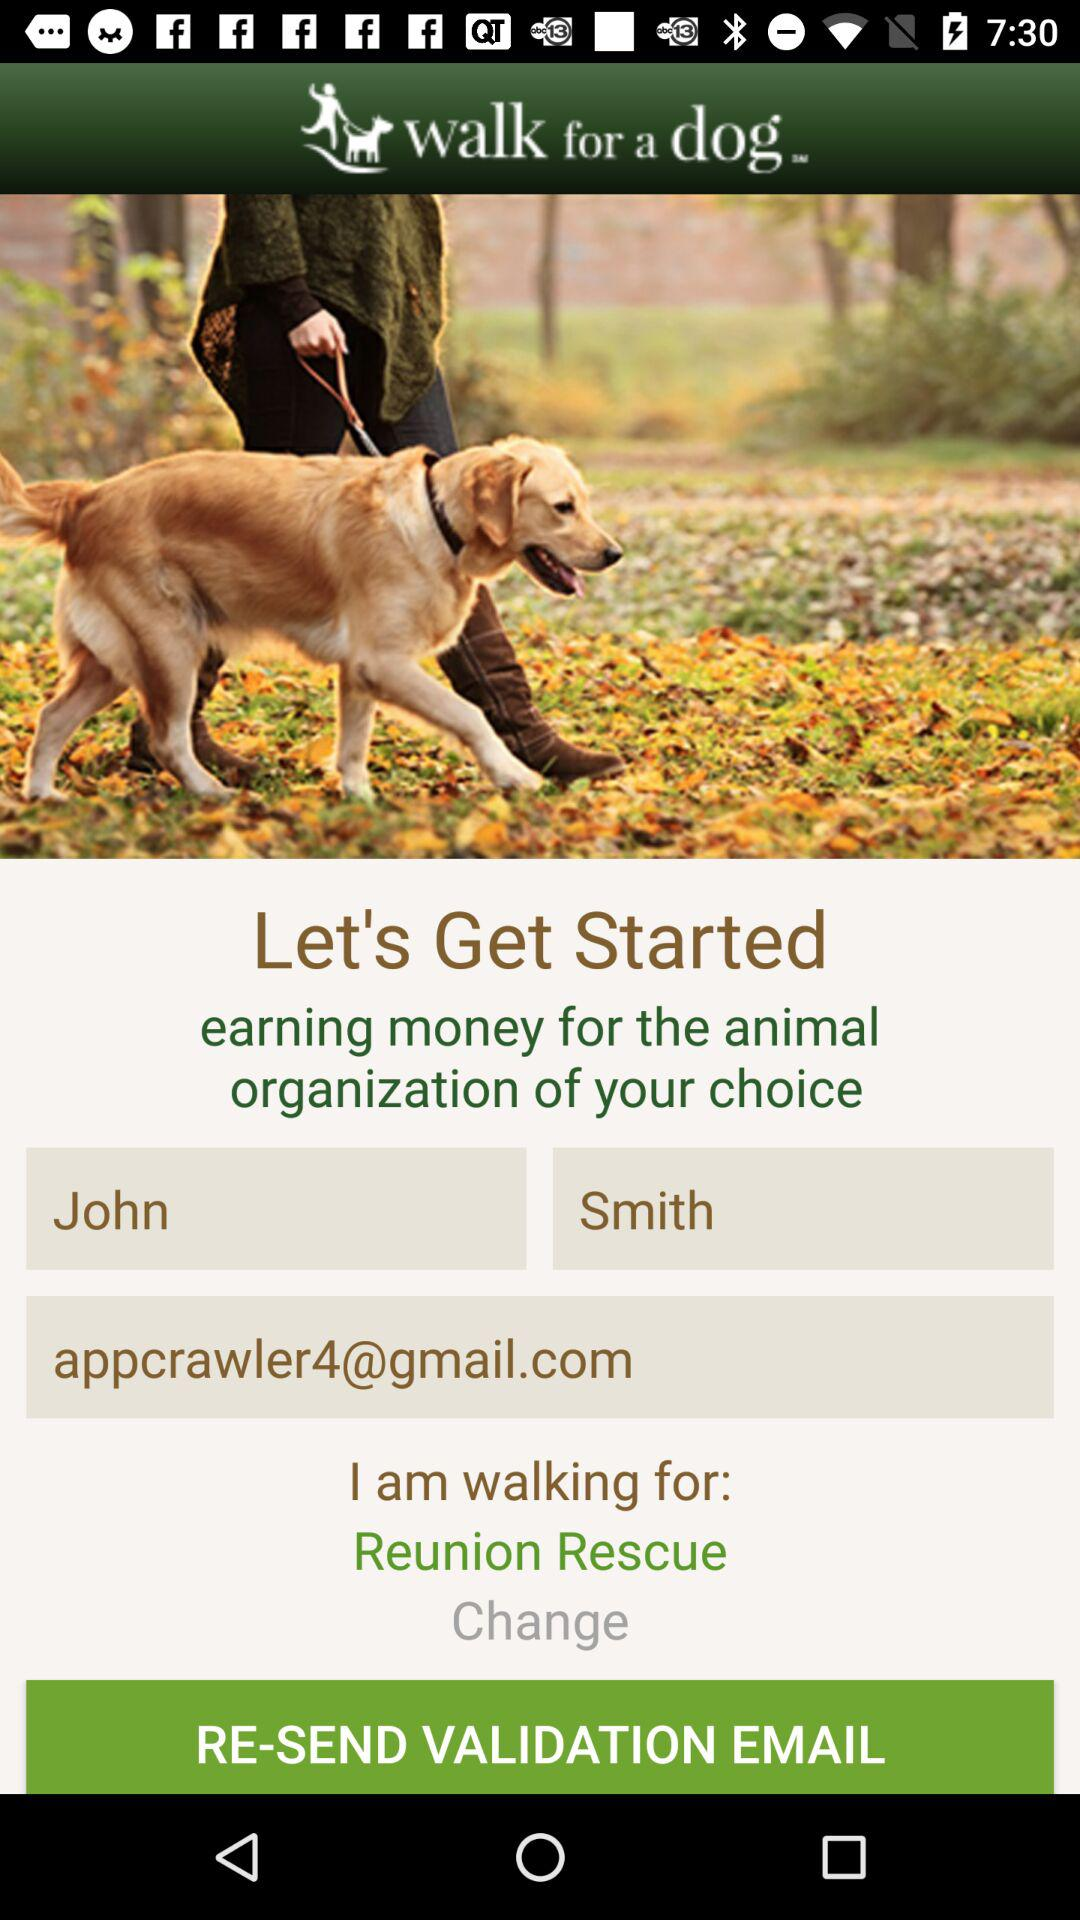What is the name? The name is John Smith. 